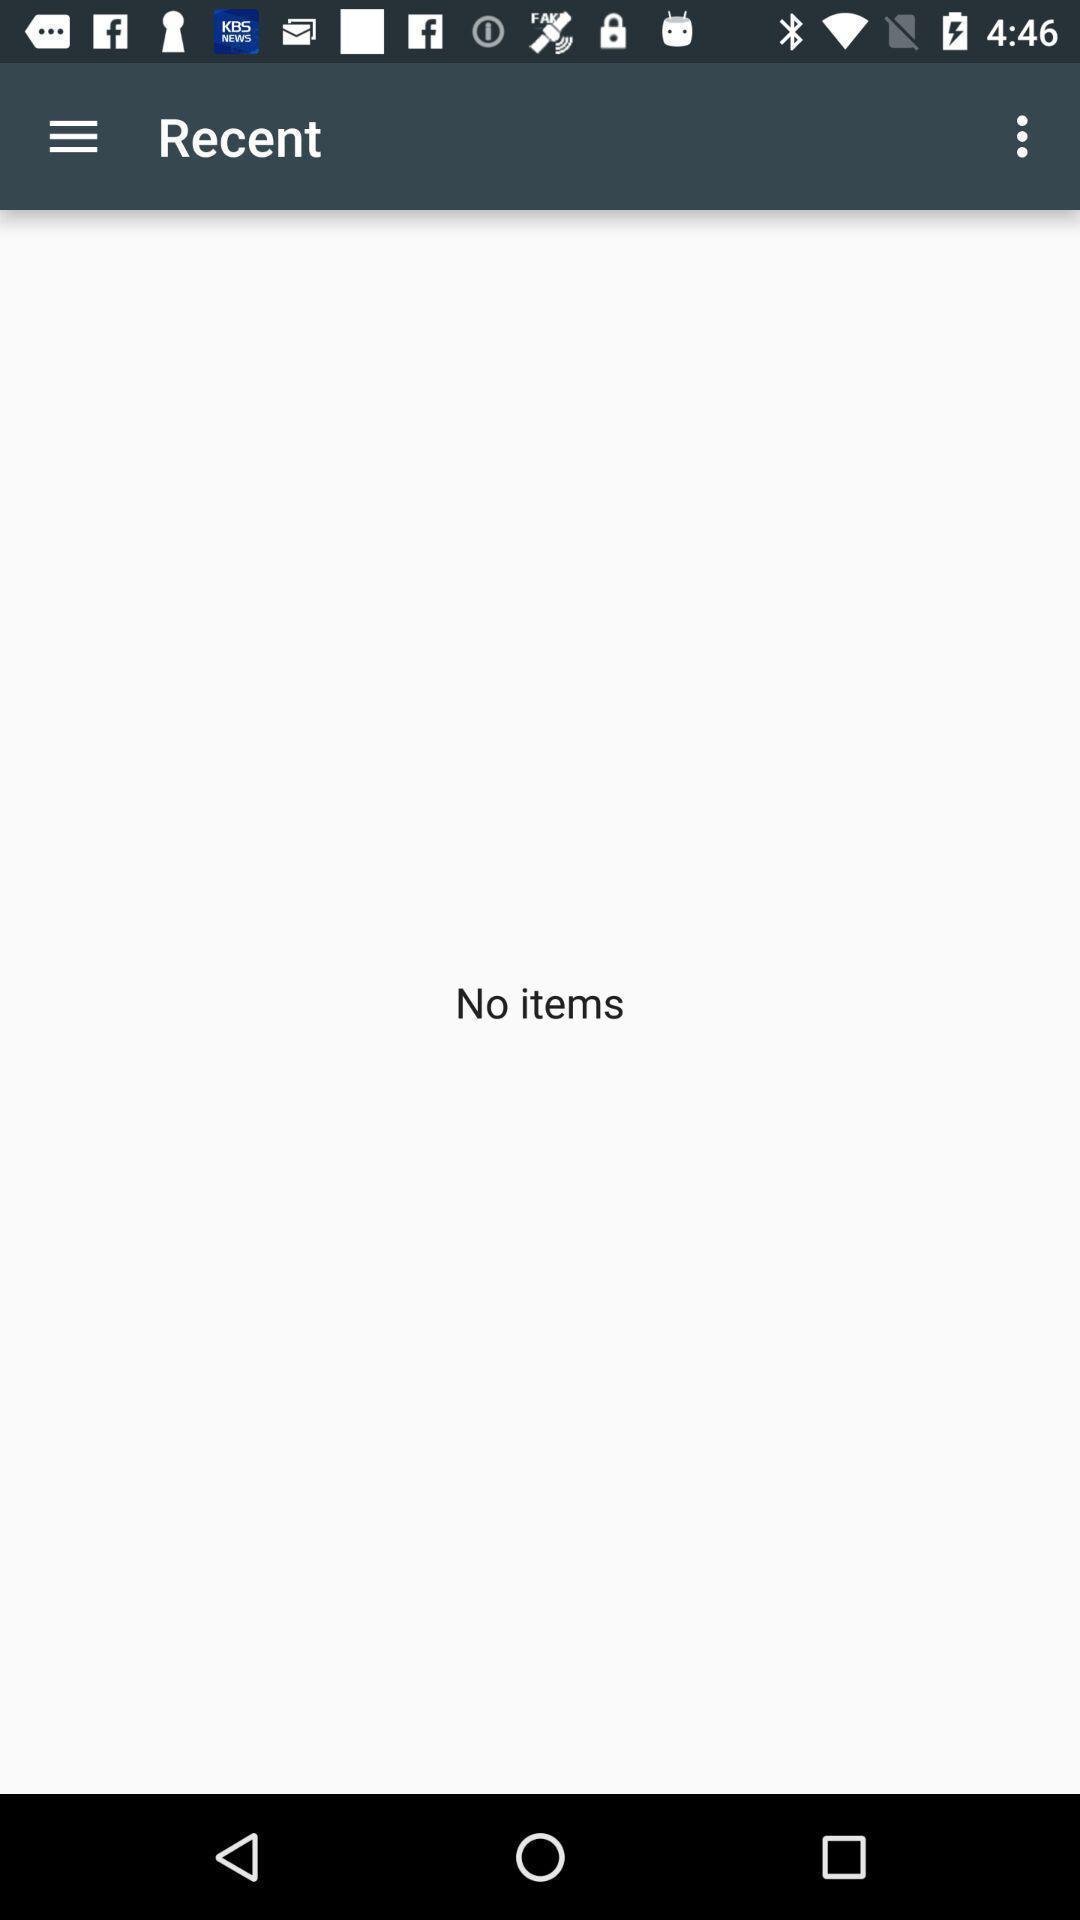Explain the elements present in this screenshot. Screen displaying recent page of app. 